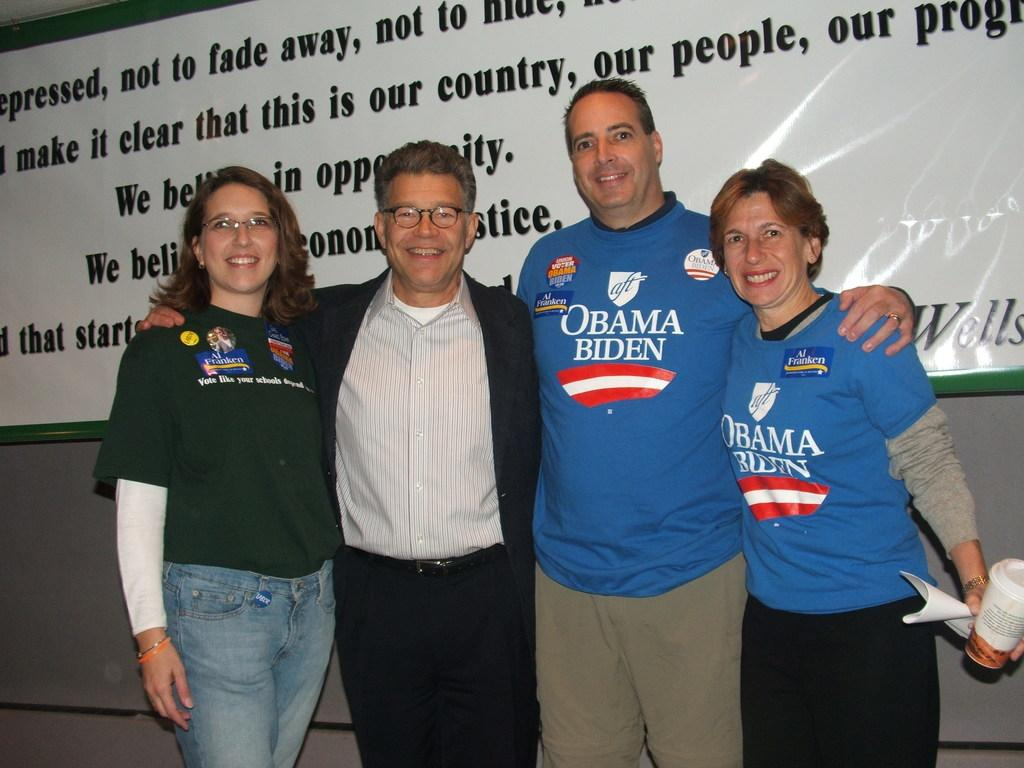<image>
Give a short and clear explanation of the subsequent image. 2 men and 2 women embraced with a couple wearing Obama/Biden shirts. 